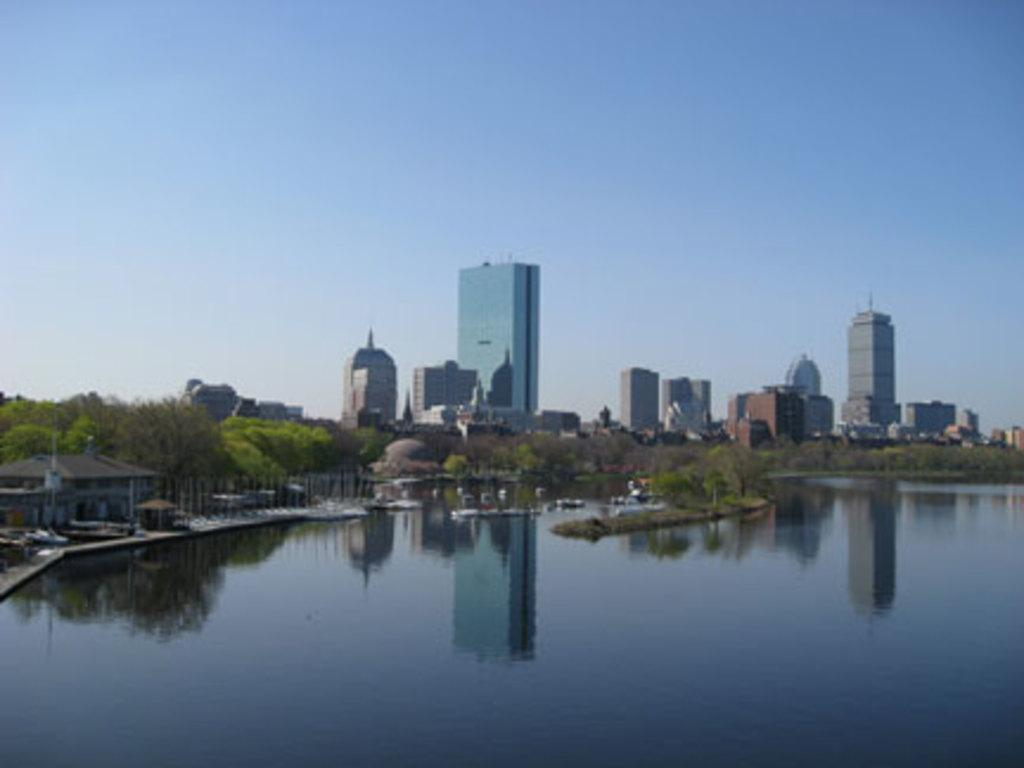What type of vegetation can be seen in the image? There are trees in the image. Where are the trees situated in relation to the river? The trees are located at the bank of a river. What type of juice is being sold by the beggar in the image? There is no beggar or juice present in the image; it only features trees at the bank of a river. 